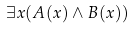<formula> <loc_0><loc_0><loc_500><loc_500>\exists x ( A ( x ) \land B ( x ) )</formula> 